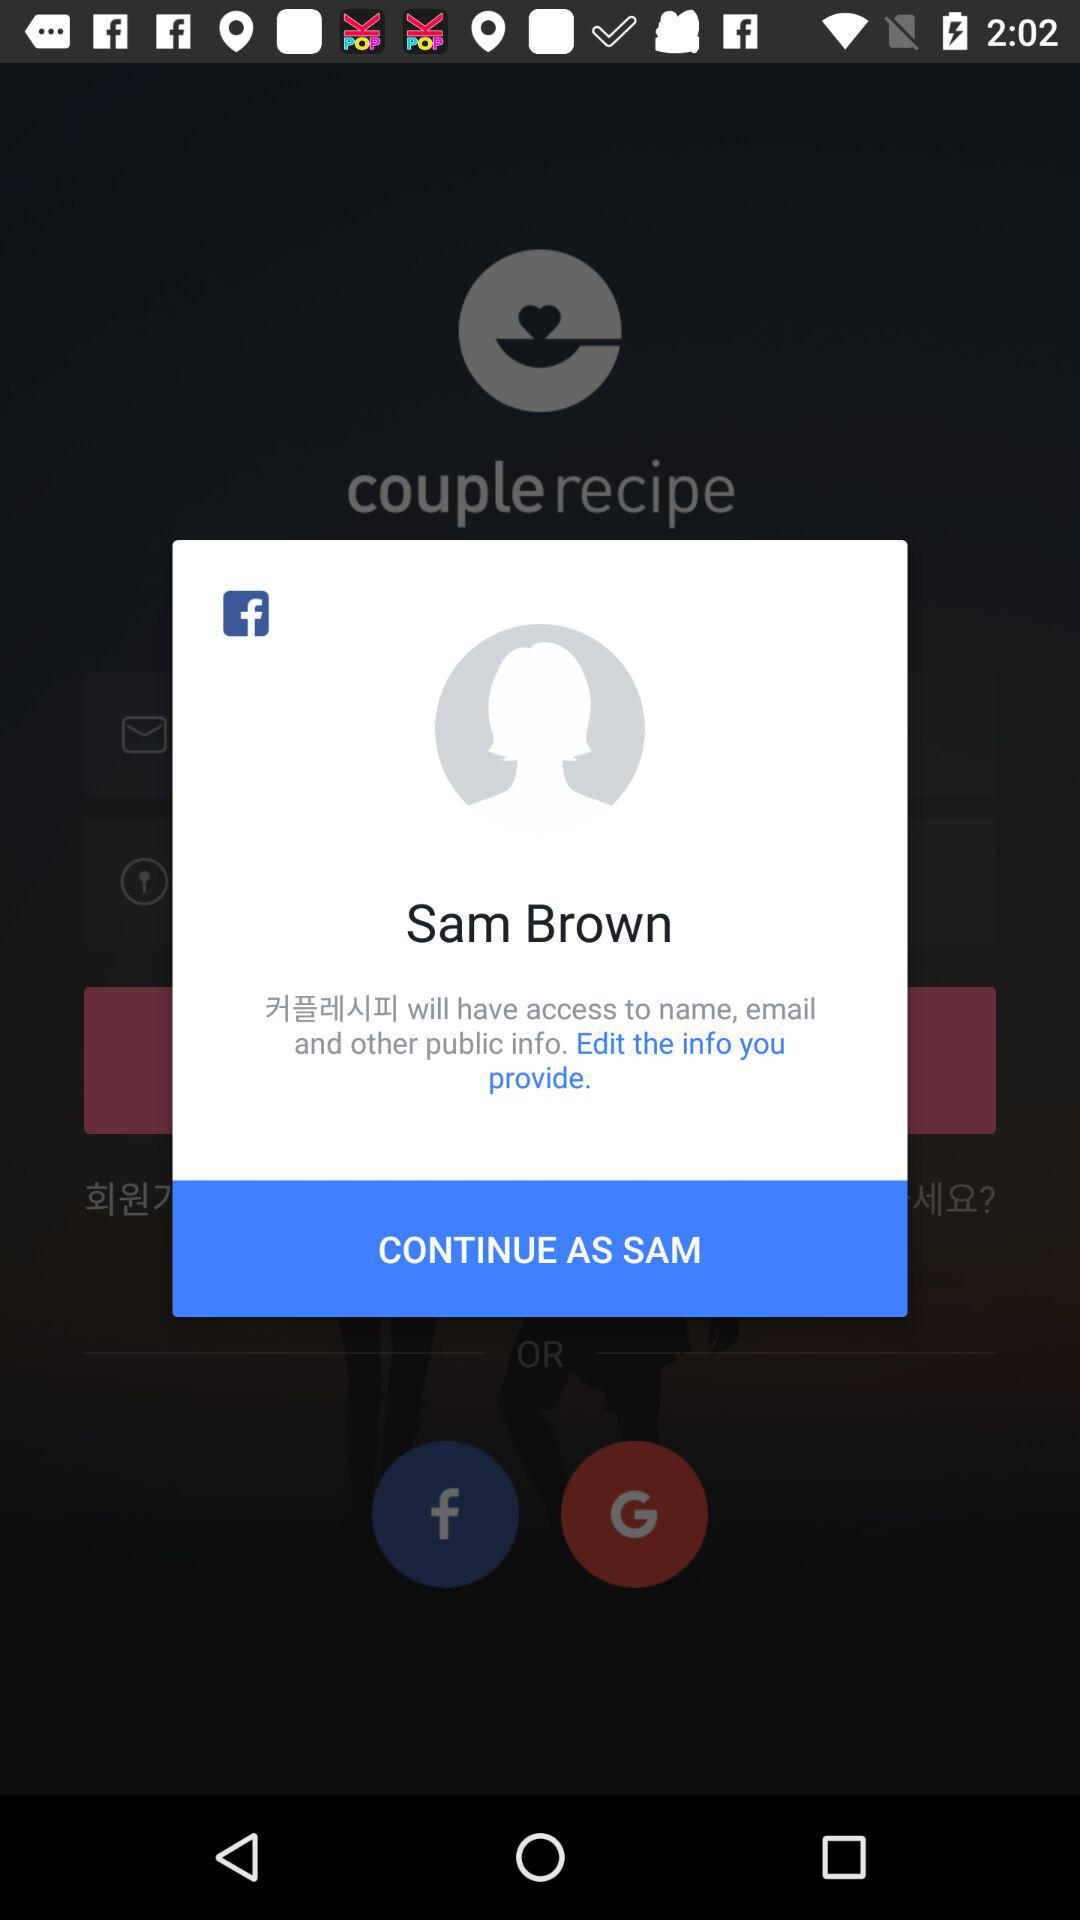What is the entered email address?
When the provided information is insufficient, respond with <no answer>. <no answer> 